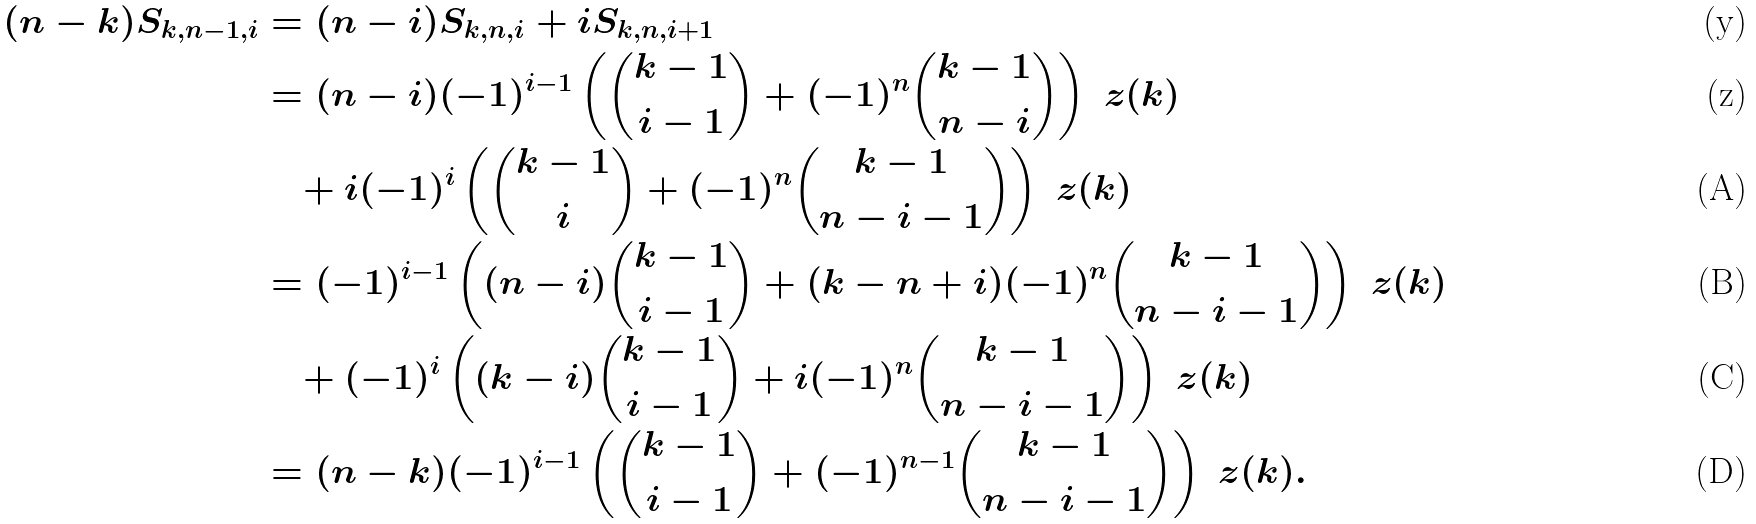<formula> <loc_0><loc_0><loc_500><loc_500>( n - k ) S _ { k , n - 1 , i } & = ( n - i ) S _ { k , n , i } + i S _ { k , n , i + 1 } \\ & = ( n - i ) ( - 1 ) ^ { i - 1 } \left ( \binom { k - 1 } { i - 1 } + ( - 1 ) ^ { n } \binom { k - 1 } { n - i } \right ) \ z ( k ) \\ & \quad + i ( - 1 ) ^ { i } \left ( \binom { k - 1 } { i } + ( - 1 ) ^ { n } \binom { k - 1 } { n - i - 1 } \right ) \ z ( k ) \\ & = ( - 1 ) ^ { i - 1 } \left ( ( n - i ) \binom { k - 1 } { i - 1 } + ( k - n + i ) ( - 1 ) ^ { n } \binom { k - 1 } { n - i - 1 } \right ) \ z ( k ) \\ & \quad + ( - 1 ) ^ { i } \left ( ( k - i ) \binom { k - 1 } { i - 1 } + i ( - 1 ) ^ { n } \binom { k - 1 } { n - i - 1 } \right ) \ z ( k ) \\ & = ( n - k ) ( - 1 ) ^ { i - 1 } \left ( \binom { k - 1 } { i - 1 } + ( - 1 ) ^ { n - 1 } \binom { k - 1 } { n - i - 1 } \right ) \ z ( k ) .</formula> 